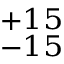Convert formula to latex. <formula><loc_0><loc_0><loc_500><loc_500>^ { + 1 5 } _ { - 1 5 }</formula> 